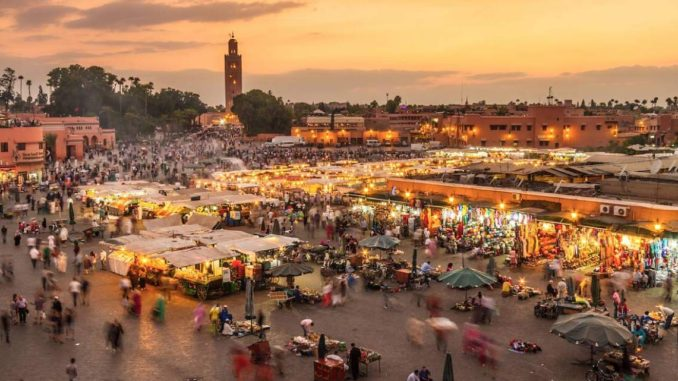If you were to write a short story inspired by this marketplace, what would be the plot? The plot of the story revolves around a young girl named Leila, who grows up in the bustling marketplace of Jemaa El Fnaa. Raised by her grandfather, who runs an antique stall with hidden magical relics, Leila discovers that she has a unique ability to perceive the stories behind every item she touches. As she learns to harness her powers, she uncovers an ancient prophecy foretelling a great upheaval in the marketplace. A shadowy sorcerer, disguised as a humble merchant, plans to use the mystical objects to plunge the city into darkness. Leila, armed with her newfound knowledge and assisted by a band of quirky market vendors, sets out on a thrilling adventure to thwart the sorcerer's plans. Along the way, she encounters talking animals, enchanted objects, and secret passages, leading to an epic showdown at the heart of the marketplace where the fate of Marrakech hangs in the balance. What do you think are the challenges in capturing the essence of such a bustling market in a photograph? Capturing the essence of a bustling market like Jemaa El Fnaa in a photograph presents several challenges. Firstly, conveying the dynamism and constant movement of the market can be difficult; a single frame may not fully capture the hustle and bustle of vendors and visitors. Secondly, the vast array of colors, sounds, and smells are hard to translate through a visual medium alone. The photographer must find a way to imply these senses through thoughtful composition and focus. Lighting is another challenge, as the market’s ambiance changes dramatically from day to night, requiring skill to balance natural and artificial light. Finally, capturing the diverse and rich cultural interactions within the market without intrusive staging demands sensitivity and a keen eye for candid moments. 